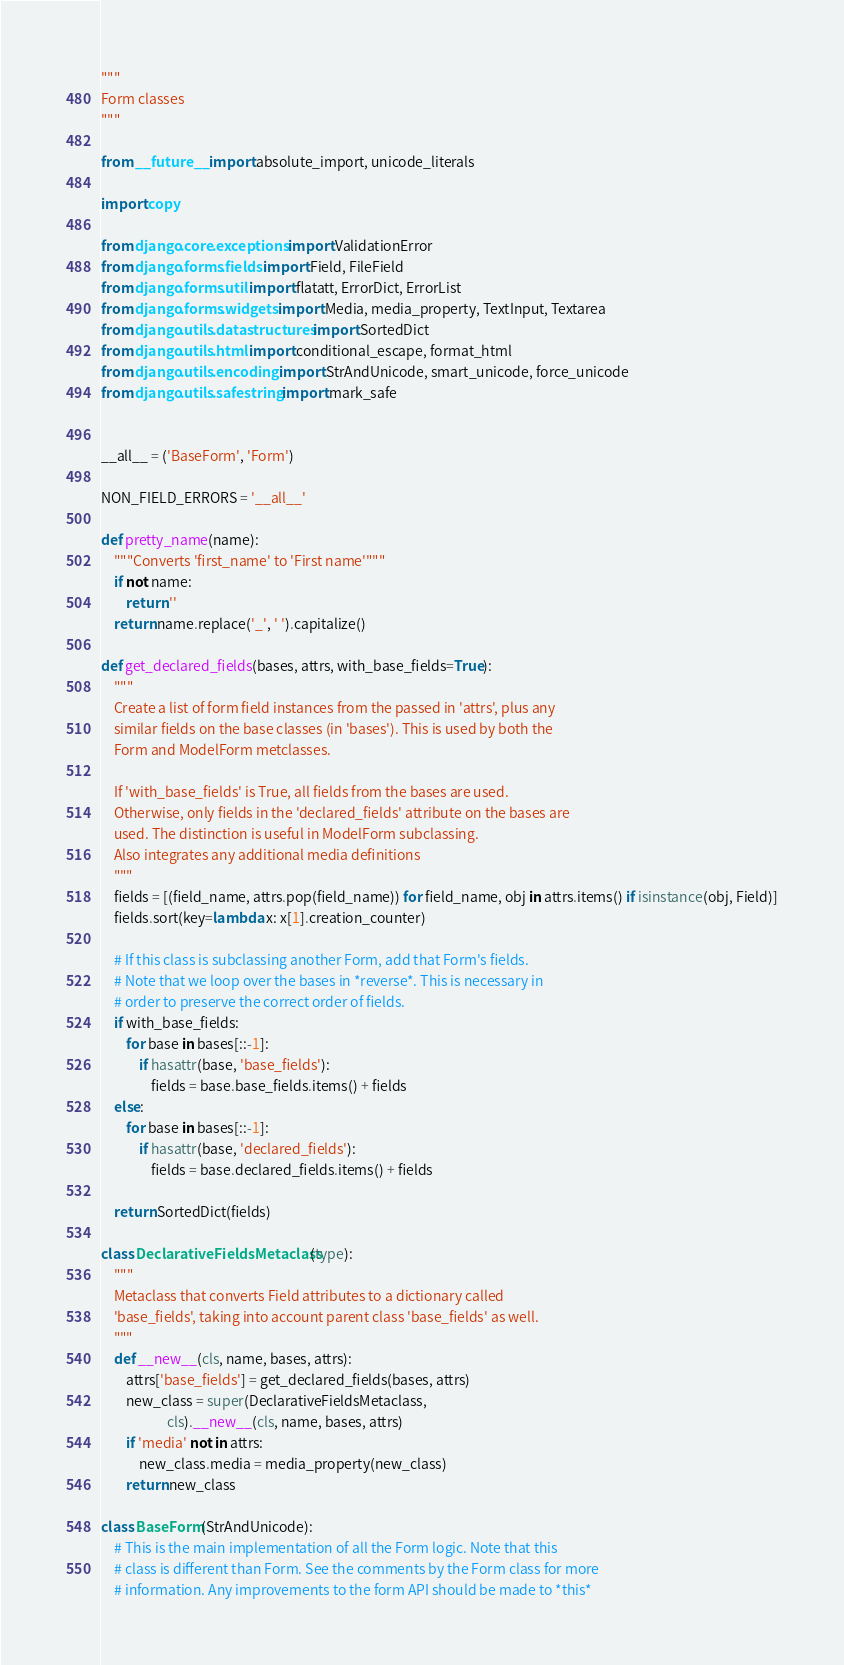<code> <loc_0><loc_0><loc_500><loc_500><_Python_>"""
Form classes
"""

from __future__ import absolute_import, unicode_literals

import copy

from django.core.exceptions import ValidationError
from django.forms.fields import Field, FileField
from django.forms.util import flatatt, ErrorDict, ErrorList
from django.forms.widgets import Media, media_property, TextInput, Textarea
from django.utils.datastructures import SortedDict
from django.utils.html import conditional_escape, format_html
from django.utils.encoding import StrAndUnicode, smart_unicode, force_unicode
from django.utils.safestring import mark_safe


__all__ = ('BaseForm', 'Form')

NON_FIELD_ERRORS = '__all__'

def pretty_name(name):
    """Converts 'first_name' to 'First name'"""
    if not name:
        return ''
    return name.replace('_', ' ').capitalize()

def get_declared_fields(bases, attrs, with_base_fields=True):
    """
    Create a list of form field instances from the passed in 'attrs', plus any
    similar fields on the base classes (in 'bases'). This is used by both the
    Form and ModelForm metclasses.

    If 'with_base_fields' is True, all fields from the bases are used.
    Otherwise, only fields in the 'declared_fields' attribute on the bases are
    used. The distinction is useful in ModelForm subclassing.
    Also integrates any additional media definitions
    """
    fields = [(field_name, attrs.pop(field_name)) for field_name, obj in attrs.items() if isinstance(obj, Field)]
    fields.sort(key=lambda x: x[1].creation_counter)

    # If this class is subclassing another Form, add that Form's fields.
    # Note that we loop over the bases in *reverse*. This is necessary in
    # order to preserve the correct order of fields.
    if with_base_fields:
        for base in bases[::-1]:
            if hasattr(base, 'base_fields'):
                fields = base.base_fields.items() + fields
    else:
        for base in bases[::-1]:
            if hasattr(base, 'declared_fields'):
                fields = base.declared_fields.items() + fields

    return SortedDict(fields)

class DeclarativeFieldsMetaclass(type):
    """
    Metaclass that converts Field attributes to a dictionary called
    'base_fields', taking into account parent class 'base_fields' as well.
    """
    def __new__(cls, name, bases, attrs):
        attrs['base_fields'] = get_declared_fields(bases, attrs)
        new_class = super(DeclarativeFieldsMetaclass,
                     cls).__new__(cls, name, bases, attrs)
        if 'media' not in attrs:
            new_class.media = media_property(new_class)
        return new_class

class BaseForm(StrAndUnicode):
    # This is the main implementation of all the Form logic. Note that this
    # class is different than Form. See the comments by the Form class for more
    # information. Any improvements to the form API should be made to *this*</code> 